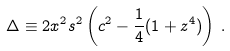<formula> <loc_0><loc_0><loc_500><loc_500>\Delta \equiv 2 x ^ { 2 } s ^ { 2 } \left ( c ^ { 2 } - \frac { 1 } { 4 } ( 1 + z ^ { 4 } ) \right ) \, .</formula> 